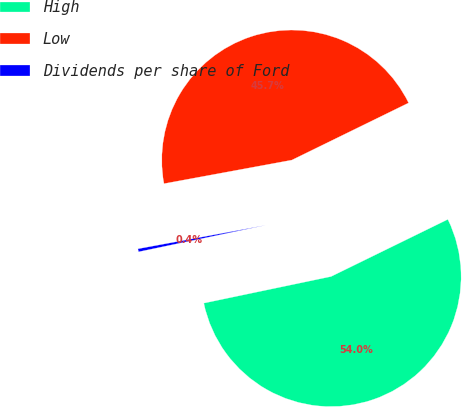<chart> <loc_0><loc_0><loc_500><loc_500><pie_chart><fcel>High<fcel>Low<fcel>Dividends per share of Ford<nl><fcel>53.96%<fcel>45.66%<fcel>0.38%<nl></chart> 